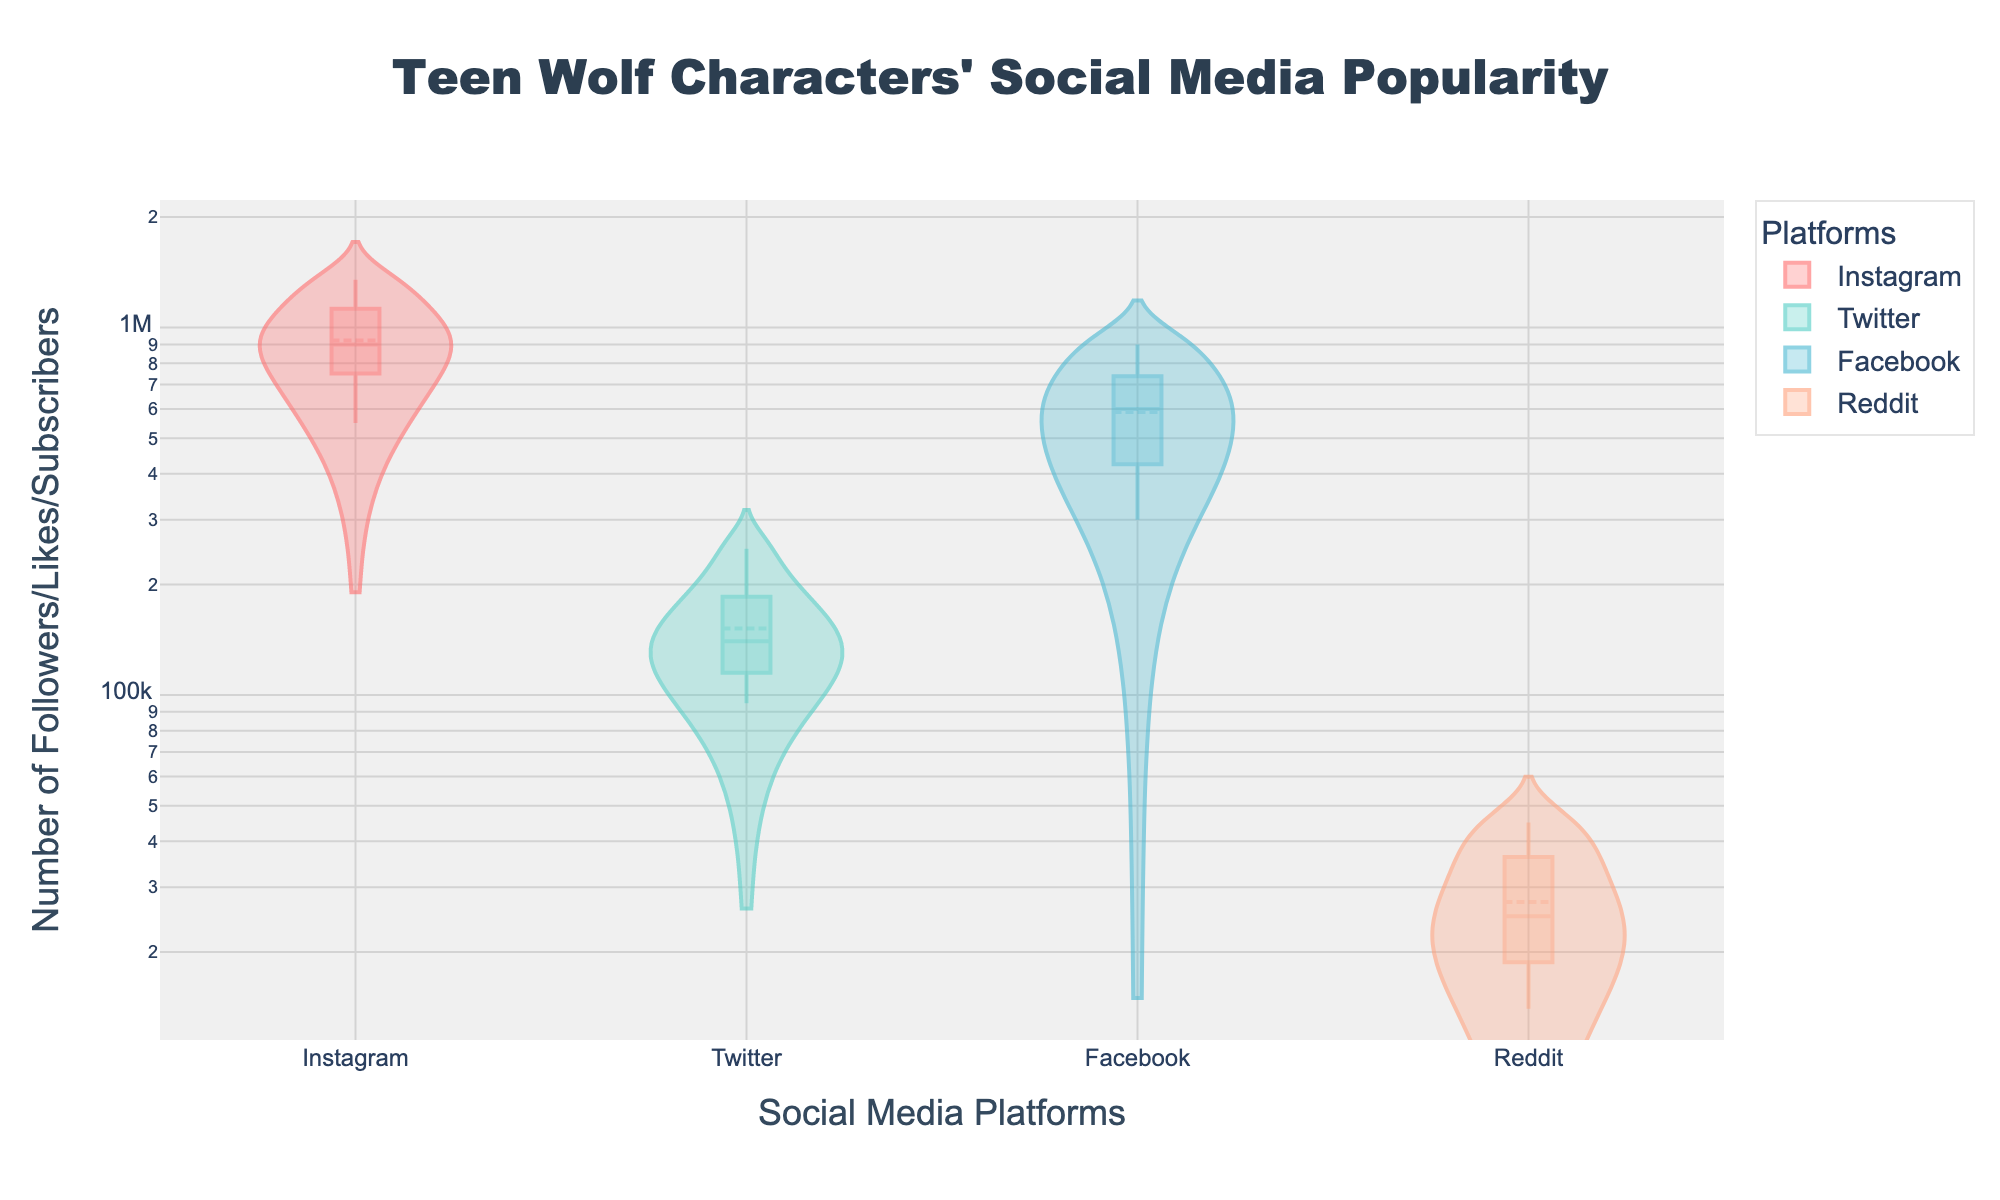What is the title of the figure? The title is located at the top of the figure and typically summarizes the content or focus. From the layout, the title is centered text specifying the content the figure is representing.
Answer: Teen Wolf Characters' Social Media Popularity Which platform has the highest number of followers for any character, and who is that character? Look at the violin plots and identify which platform's plot has the highest individual data point. For Instagram, Scott McCall has the highest at 1,350,000 followers.
Answer: Instagram, Scott McCall How do the median values of Instagram and Twitter followers compare? Examine the median lines in both the Instagram and Twitter violin plots. The median for Instagram appears higher than that for Twitter.
Answer: Instagram median is higher What is the range of Facebook Likes displayed in the figure? The range is defined by the minimum and maximum values in a dataset. The Facebook Likes violin plot shows values from around 300,000 to 900,000.
Answer: 300,000 to 900,000 Which character has the least Reddit subscribers and what is that number? Look for the character with the lowest data point in the Reddit violin plot. Jackson Whittemore has the least with 14,000 subscribers.
Answer: Jackson Whittemore, 14,000 Is there a platform where the popularity of characters appears more uniform? One can determine uniformity by looking at how spread out the data points are within a violin plot. The Reddit violin plot appears less spread out compared to others, indicating more uniformity in subscriber numbers.
Answer: Reddit What is the difference between the highest and lowest Instagram followers? Identify the highest (Scott McCall: 1,350,000) and lowest (Jackson Whittemore: 550,000) values in the Instagram violin plot and subtract the smallest value from the largest.
Answer: 800,000 Which platform shows the largest variance in popularity among the characters? Variance can be visually approximated by the spread of the data points in each violin plot. Instagram's plot is the widest, indicating the most variance among characters' followers.
Answer: Instagram What's the mean follower count for Twitter across all characters? Locate the mean line in the Twitter violin plot and interpret its value. The mean line indicates the average number of Twitter followers, which appears to be around 154,000.
Answer: 154,000 How does the box plot within each violin plot help in understanding the data? The box plot within the violin plot shows the interquartile range and median, providing precise statistically useful summaries alongside the distribution of data shown by the violin plot. This can help understand the concentration and spread of data points.
Answer: Shows interquartile range and median 